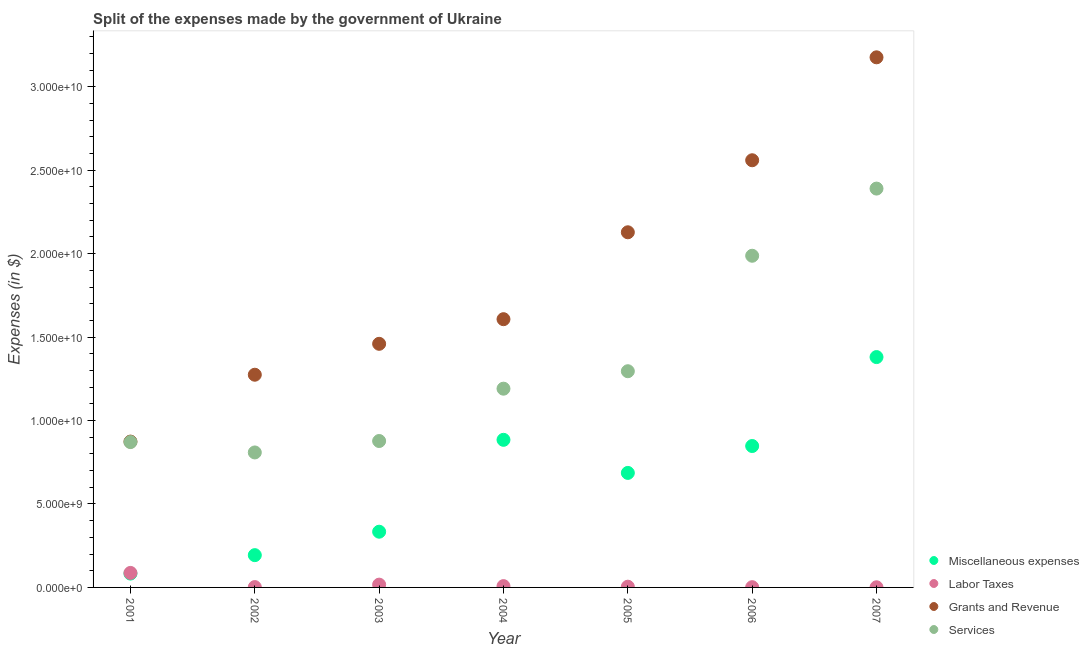Is the number of dotlines equal to the number of legend labels?
Ensure brevity in your answer.  Yes. What is the amount spent on services in 2003?
Ensure brevity in your answer.  8.77e+09. Across all years, what is the maximum amount spent on miscellaneous expenses?
Provide a succinct answer. 1.38e+1. Across all years, what is the minimum amount spent on grants and revenue?
Ensure brevity in your answer.  8.74e+09. What is the total amount spent on miscellaneous expenses in the graph?
Your response must be concise. 4.41e+1. What is the difference between the amount spent on grants and revenue in 2001 and that in 2002?
Your response must be concise. -4.01e+09. What is the difference between the amount spent on services in 2004 and the amount spent on miscellaneous expenses in 2005?
Give a very brief answer. 5.05e+09. What is the average amount spent on miscellaneous expenses per year?
Make the answer very short. 6.30e+09. In the year 2003, what is the difference between the amount spent on services and amount spent on labor taxes?
Your answer should be compact. 8.60e+09. In how many years, is the amount spent on labor taxes greater than 23000000000 $?
Your answer should be compact. 0. What is the ratio of the amount spent on services in 2004 to that in 2005?
Ensure brevity in your answer.  0.92. What is the difference between the highest and the second highest amount spent on miscellaneous expenses?
Offer a very short reply. 4.96e+09. What is the difference between the highest and the lowest amount spent on grants and revenue?
Make the answer very short. 2.30e+1. In how many years, is the amount spent on grants and revenue greater than the average amount spent on grants and revenue taken over all years?
Provide a short and direct response. 3. Is the sum of the amount spent on labor taxes in 2003 and 2004 greater than the maximum amount spent on services across all years?
Offer a terse response. No. Is it the case that in every year, the sum of the amount spent on miscellaneous expenses and amount spent on labor taxes is greater than the amount spent on grants and revenue?
Keep it short and to the point. No. Is the amount spent on services strictly greater than the amount spent on labor taxes over the years?
Provide a short and direct response. Yes. Is the amount spent on services strictly less than the amount spent on miscellaneous expenses over the years?
Provide a short and direct response. No. What is the difference between two consecutive major ticks on the Y-axis?
Your response must be concise. 5.00e+09. Are the values on the major ticks of Y-axis written in scientific E-notation?
Offer a terse response. Yes. How many legend labels are there?
Offer a very short reply. 4. What is the title of the graph?
Your response must be concise. Split of the expenses made by the government of Ukraine. What is the label or title of the Y-axis?
Your answer should be very brief. Expenses (in $). What is the Expenses (in $) of Miscellaneous expenses in 2001?
Offer a very short reply. 8.29e+08. What is the Expenses (in $) in Labor Taxes in 2001?
Provide a succinct answer. 8.69e+08. What is the Expenses (in $) in Grants and Revenue in 2001?
Make the answer very short. 8.74e+09. What is the Expenses (in $) in Services in 2001?
Provide a short and direct response. 8.71e+09. What is the Expenses (in $) of Miscellaneous expenses in 2002?
Make the answer very short. 1.93e+09. What is the Expenses (in $) of Labor Taxes in 2002?
Provide a succinct answer. 2.07e+07. What is the Expenses (in $) of Grants and Revenue in 2002?
Your answer should be compact. 1.27e+1. What is the Expenses (in $) in Services in 2002?
Offer a very short reply. 8.09e+09. What is the Expenses (in $) in Miscellaneous expenses in 2003?
Offer a terse response. 3.34e+09. What is the Expenses (in $) of Labor Taxes in 2003?
Provide a short and direct response. 1.67e+08. What is the Expenses (in $) in Grants and Revenue in 2003?
Offer a very short reply. 1.46e+1. What is the Expenses (in $) in Services in 2003?
Give a very brief answer. 8.77e+09. What is the Expenses (in $) in Miscellaneous expenses in 2004?
Make the answer very short. 8.84e+09. What is the Expenses (in $) of Labor Taxes in 2004?
Offer a terse response. 7.85e+07. What is the Expenses (in $) of Grants and Revenue in 2004?
Offer a terse response. 1.61e+1. What is the Expenses (in $) of Services in 2004?
Offer a very short reply. 1.19e+1. What is the Expenses (in $) in Miscellaneous expenses in 2005?
Provide a short and direct response. 6.86e+09. What is the Expenses (in $) of Labor Taxes in 2005?
Ensure brevity in your answer.  4.35e+07. What is the Expenses (in $) in Grants and Revenue in 2005?
Offer a very short reply. 2.13e+1. What is the Expenses (in $) of Services in 2005?
Offer a terse response. 1.30e+1. What is the Expenses (in $) of Miscellaneous expenses in 2006?
Your answer should be very brief. 8.47e+09. What is the Expenses (in $) in Labor Taxes in 2006?
Your response must be concise. 1.44e+07. What is the Expenses (in $) of Grants and Revenue in 2006?
Provide a succinct answer. 2.56e+1. What is the Expenses (in $) of Services in 2006?
Ensure brevity in your answer.  1.99e+1. What is the Expenses (in $) in Miscellaneous expenses in 2007?
Offer a terse response. 1.38e+1. What is the Expenses (in $) in Labor Taxes in 2007?
Keep it short and to the point. 8.40e+06. What is the Expenses (in $) of Grants and Revenue in 2007?
Provide a succinct answer. 3.18e+1. What is the Expenses (in $) of Services in 2007?
Your answer should be very brief. 2.39e+1. Across all years, what is the maximum Expenses (in $) of Miscellaneous expenses?
Make the answer very short. 1.38e+1. Across all years, what is the maximum Expenses (in $) of Labor Taxes?
Your answer should be very brief. 8.69e+08. Across all years, what is the maximum Expenses (in $) of Grants and Revenue?
Provide a succinct answer. 3.18e+1. Across all years, what is the maximum Expenses (in $) of Services?
Offer a terse response. 2.39e+1. Across all years, what is the minimum Expenses (in $) in Miscellaneous expenses?
Ensure brevity in your answer.  8.29e+08. Across all years, what is the minimum Expenses (in $) of Labor Taxes?
Keep it short and to the point. 8.40e+06. Across all years, what is the minimum Expenses (in $) in Grants and Revenue?
Offer a terse response. 8.74e+09. Across all years, what is the minimum Expenses (in $) in Services?
Offer a terse response. 8.09e+09. What is the total Expenses (in $) of Miscellaneous expenses in the graph?
Make the answer very short. 4.41e+1. What is the total Expenses (in $) in Labor Taxes in the graph?
Give a very brief answer. 1.20e+09. What is the total Expenses (in $) in Grants and Revenue in the graph?
Your response must be concise. 1.31e+11. What is the total Expenses (in $) in Services in the graph?
Your response must be concise. 9.42e+1. What is the difference between the Expenses (in $) in Miscellaneous expenses in 2001 and that in 2002?
Keep it short and to the point. -1.10e+09. What is the difference between the Expenses (in $) of Labor Taxes in 2001 and that in 2002?
Ensure brevity in your answer.  8.48e+08. What is the difference between the Expenses (in $) in Grants and Revenue in 2001 and that in 2002?
Ensure brevity in your answer.  -4.01e+09. What is the difference between the Expenses (in $) of Services in 2001 and that in 2002?
Ensure brevity in your answer.  6.23e+08. What is the difference between the Expenses (in $) of Miscellaneous expenses in 2001 and that in 2003?
Provide a succinct answer. -2.51e+09. What is the difference between the Expenses (in $) in Labor Taxes in 2001 and that in 2003?
Provide a succinct answer. 7.02e+08. What is the difference between the Expenses (in $) in Grants and Revenue in 2001 and that in 2003?
Make the answer very short. -5.86e+09. What is the difference between the Expenses (in $) of Services in 2001 and that in 2003?
Your response must be concise. -6.23e+07. What is the difference between the Expenses (in $) in Miscellaneous expenses in 2001 and that in 2004?
Make the answer very short. -8.01e+09. What is the difference between the Expenses (in $) in Labor Taxes in 2001 and that in 2004?
Your answer should be very brief. 7.91e+08. What is the difference between the Expenses (in $) in Grants and Revenue in 2001 and that in 2004?
Your answer should be compact. -7.33e+09. What is the difference between the Expenses (in $) of Services in 2001 and that in 2004?
Your response must be concise. -3.20e+09. What is the difference between the Expenses (in $) in Miscellaneous expenses in 2001 and that in 2005?
Offer a terse response. -6.03e+09. What is the difference between the Expenses (in $) of Labor Taxes in 2001 and that in 2005?
Ensure brevity in your answer.  8.26e+08. What is the difference between the Expenses (in $) in Grants and Revenue in 2001 and that in 2005?
Your answer should be very brief. -1.25e+1. What is the difference between the Expenses (in $) of Services in 2001 and that in 2005?
Your answer should be very brief. -4.24e+09. What is the difference between the Expenses (in $) in Miscellaneous expenses in 2001 and that in 2006?
Provide a succinct answer. -7.64e+09. What is the difference between the Expenses (in $) in Labor Taxes in 2001 and that in 2006?
Your response must be concise. 8.55e+08. What is the difference between the Expenses (in $) of Grants and Revenue in 2001 and that in 2006?
Provide a succinct answer. -1.69e+1. What is the difference between the Expenses (in $) in Services in 2001 and that in 2006?
Keep it short and to the point. -1.12e+1. What is the difference between the Expenses (in $) in Miscellaneous expenses in 2001 and that in 2007?
Provide a short and direct response. -1.30e+1. What is the difference between the Expenses (in $) in Labor Taxes in 2001 and that in 2007?
Provide a short and direct response. 8.61e+08. What is the difference between the Expenses (in $) of Grants and Revenue in 2001 and that in 2007?
Give a very brief answer. -2.30e+1. What is the difference between the Expenses (in $) in Services in 2001 and that in 2007?
Give a very brief answer. -1.52e+1. What is the difference between the Expenses (in $) of Miscellaneous expenses in 2002 and that in 2003?
Your answer should be very brief. -1.40e+09. What is the difference between the Expenses (in $) in Labor Taxes in 2002 and that in 2003?
Your answer should be compact. -1.47e+08. What is the difference between the Expenses (in $) in Grants and Revenue in 2002 and that in 2003?
Offer a very short reply. -1.85e+09. What is the difference between the Expenses (in $) of Services in 2002 and that in 2003?
Provide a succinct answer. -6.85e+08. What is the difference between the Expenses (in $) in Miscellaneous expenses in 2002 and that in 2004?
Ensure brevity in your answer.  -6.91e+09. What is the difference between the Expenses (in $) of Labor Taxes in 2002 and that in 2004?
Keep it short and to the point. -5.78e+07. What is the difference between the Expenses (in $) of Grants and Revenue in 2002 and that in 2004?
Ensure brevity in your answer.  -3.33e+09. What is the difference between the Expenses (in $) of Services in 2002 and that in 2004?
Give a very brief answer. -3.82e+09. What is the difference between the Expenses (in $) of Miscellaneous expenses in 2002 and that in 2005?
Provide a short and direct response. -4.93e+09. What is the difference between the Expenses (in $) in Labor Taxes in 2002 and that in 2005?
Provide a succinct answer. -2.28e+07. What is the difference between the Expenses (in $) of Grants and Revenue in 2002 and that in 2005?
Offer a very short reply. -8.53e+09. What is the difference between the Expenses (in $) of Services in 2002 and that in 2005?
Your answer should be very brief. -4.87e+09. What is the difference between the Expenses (in $) of Miscellaneous expenses in 2002 and that in 2006?
Provide a succinct answer. -6.54e+09. What is the difference between the Expenses (in $) of Labor Taxes in 2002 and that in 2006?
Keep it short and to the point. 6.30e+06. What is the difference between the Expenses (in $) in Grants and Revenue in 2002 and that in 2006?
Give a very brief answer. -1.29e+1. What is the difference between the Expenses (in $) in Services in 2002 and that in 2006?
Ensure brevity in your answer.  -1.18e+1. What is the difference between the Expenses (in $) in Miscellaneous expenses in 2002 and that in 2007?
Offer a very short reply. -1.19e+1. What is the difference between the Expenses (in $) of Labor Taxes in 2002 and that in 2007?
Your answer should be compact. 1.23e+07. What is the difference between the Expenses (in $) of Grants and Revenue in 2002 and that in 2007?
Keep it short and to the point. -1.90e+1. What is the difference between the Expenses (in $) of Services in 2002 and that in 2007?
Your answer should be very brief. -1.58e+1. What is the difference between the Expenses (in $) in Miscellaneous expenses in 2003 and that in 2004?
Provide a short and direct response. -5.51e+09. What is the difference between the Expenses (in $) of Labor Taxes in 2003 and that in 2004?
Provide a succinct answer. 8.90e+07. What is the difference between the Expenses (in $) in Grants and Revenue in 2003 and that in 2004?
Offer a terse response. -1.48e+09. What is the difference between the Expenses (in $) in Services in 2003 and that in 2004?
Keep it short and to the point. -3.14e+09. What is the difference between the Expenses (in $) in Miscellaneous expenses in 2003 and that in 2005?
Make the answer very short. -3.52e+09. What is the difference between the Expenses (in $) in Labor Taxes in 2003 and that in 2005?
Offer a terse response. 1.24e+08. What is the difference between the Expenses (in $) of Grants and Revenue in 2003 and that in 2005?
Provide a short and direct response. -6.68e+09. What is the difference between the Expenses (in $) of Services in 2003 and that in 2005?
Your response must be concise. -4.18e+09. What is the difference between the Expenses (in $) of Miscellaneous expenses in 2003 and that in 2006?
Provide a succinct answer. -5.13e+09. What is the difference between the Expenses (in $) in Labor Taxes in 2003 and that in 2006?
Offer a terse response. 1.53e+08. What is the difference between the Expenses (in $) in Grants and Revenue in 2003 and that in 2006?
Ensure brevity in your answer.  -1.10e+1. What is the difference between the Expenses (in $) of Services in 2003 and that in 2006?
Provide a short and direct response. -1.11e+1. What is the difference between the Expenses (in $) of Miscellaneous expenses in 2003 and that in 2007?
Give a very brief answer. -1.05e+1. What is the difference between the Expenses (in $) of Labor Taxes in 2003 and that in 2007?
Keep it short and to the point. 1.59e+08. What is the difference between the Expenses (in $) of Grants and Revenue in 2003 and that in 2007?
Give a very brief answer. -1.72e+1. What is the difference between the Expenses (in $) in Services in 2003 and that in 2007?
Your answer should be compact. -1.51e+1. What is the difference between the Expenses (in $) in Miscellaneous expenses in 2004 and that in 2005?
Your answer should be compact. 1.98e+09. What is the difference between the Expenses (in $) in Labor Taxes in 2004 and that in 2005?
Keep it short and to the point. 3.50e+07. What is the difference between the Expenses (in $) in Grants and Revenue in 2004 and that in 2005?
Make the answer very short. -5.21e+09. What is the difference between the Expenses (in $) of Services in 2004 and that in 2005?
Provide a succinct answer. -1.05e+09. What is the difference between the Expenses (in $) of Miscellaneous expenses in 2004 and that in 2006?
Keep it short and to the point. 3.71e+08. What is the difference between the Expenses (in $) of Labor Taxes in 2004 and that in 2006?
Provide a succinct answer. 6.41e+07. What is the difference between the Expenses (in $) in Grants and Revenue in 2004 and that in 2006?
Ensure brevity in your answer.  -9.52e+09. What is the difference between the Expenses (in $) of Services in 2004 and that in 2006?
Provide a short and direct response. -7.96e+09. What is the difference between the Expenses (in $) in Miscellaneous expenses in 2004 and that in 2007?
Keep it short and to the point. -4.96e+09. What is the difference between the Expenses (in $) in Labor Taxes in 2004 and that in 2007?
Your answer should be very brief. 7.01e+07. What is the difference between the Expenses (in $) in Grants and Revenue in 2004 and that in 2007?
Provide a succinct answer. -1.57e+1. What is the difference between the Expenses (in $) of Services in 2004 and that in 2007?
Your answer should be very brief. -1.20e+1. What is the difference between the Expenses (in $) in Miscellaneous expenses in 2005 and that in 2006?
Your answer should be compact. -1.61e+09. What is the difference between the Expenses (in $) in Labor Taxes in 2005 and that in 2006?
Provide a succinct answer. 2.91e+07. What is the difference between the Expenses (in $) of Grants and Revenue in 2005 and that in 2006?
Your response must be concise. -4.32e+09. What is the difference between the Expenses (in $) in Services in 2005 and that in 2006?
Offer a very short reply. -6.92e+09. What is the difference between the Expenses (in $) of Miscellaneous expenses in 2005 and that in 2007?
Make the answer very short. -6.94e+09. What is the difference between the Expenses (in $) in Labor Taxes in 2005 and that in 2007?
Keep it short and to the point. 3.51e+07. What is the difference between the Expenses (in $) of Grants and Revenue in 2005 and that in 2007?
Your response must be concise. -1.05e+1. What is the difference between the Expenses (in $) in Services in 2005 and that in 2007?
Give a very brief answer. -1.09e+1. What is the difference between the Expenses (in $) of Miscellaneous expenses in 2006 and that in 2007?
Keep it short and to the point. -5.33e+09. What is the difference between the Expenses (in $) of Labor Taxes in 2006 and that in 2007?
Your response must be concise. 6.00e+06. What is the difference between the Expenses (in $) in Grants and Revenue in 2006 and that in 2007?
Your answer should be compact. -6.17e+09. What is the difference between the Expenses (in $) in Services in 2006 and that in 2007?
Provide a succinct answer. -4.02e+09. What is the difference between the Expenses (in $) of Miscellaneous expenses in 2001 and the Expenses (in $) of Labor Taxes in 2002?
Your answer should be very brief. 8.09e+08. What is the difference between the Expenses (in $) in Miscellaneous expenses in 2001 and the Expenses (in $) in Grants and Revenue in 2002?
Keep it short and to the point. -1.19e+1. What is the difference between the Expenses (in $) in Miscellaneous expenses in 2001 and the Expenses (in $) in Services in 2002?
Provide a short and direct response. -7.26e+09. What is the difference between the Expenses (in $) in Labor Taxes in 2001 and the Expenses (in $) in Grants and Revenue in 2002?
Give a very brief answer. -1.19e+1. What is the difference between the Expenses (in $) of Labor Taxes in 2001 and the Expenses (in $) of Services in 2002?
Ensure brevity in your answer.  -7.22e+09. What is the difference between the Expenses (in $) of Grants and Revenue in 2001 and the Expenses (in $) of Services in 2002?
Provide a short and direct response. 6.51e+08. What is the difference between the Expenses (in $) in Miscellaneous expenses in 2001 and the Expenses (in $) in Labor Taxes in 2003?
Ensure brevity in your answer.  6.62e+08. What is the difference between the Expenses (in $) of Miscellaneous expenses in 2001 and the Expenses (in $) of Grants and Revenue in 2003?
Your answer should be compact. -1.38e+1. What is the difference between the Expenses (in $) in Miscellaneous expenses in 2001 and the Expenses (in $) in Services in 2003?
Provide a short and direct response. -7.94e+09. What is the difference between the Expenses (in $) in Labor Taxes in 2001 and the Expenses (in $) in Grants and Revenue in 2003?
Keep it short and to the point. -1.37e+1. What is the difference between the Expenses (in $) of Labor Taxes in 2001 and the Expenses (in $) of Services in 2003?
Provide a succinct answer. -7.90e+09. What is the difference between the Expenses (in $) of Grants and Revenue in 2001 and the Expenses (in $) of Services in 2003?
Give a very brief answer. -3.42e+07. What is the difference between the Expenses (in $) in Miscellaneous expenses in 2001 and the Expenses (in $) in Labor Taxes in 2004?
Your answer should be compact. 7.51e+08. What is the difference between the Expenses (in $) in Miscellaneous expenses in 2001 and the Expenses (in $) in Grants and Revenue in 2004?
Provide a succinct answer. -1.52e+1. What is the difference between the Expenses (in $) in Miscellaneous expenses in 2001 and the Expenses (in $) in Services in 2004?
Give a very brief answer. -1.11e+1. What is the difference between the Expenses (in $) in Labor Taxes in 2001 and the Expenses (in $) in Grants and Revenue in 2004?
Ensure brevity in your answer.  -1.52e+1. What is the difference between the Expenses (in $) of Labor Taxes in 2001 and the Expenses (in $) of Services in 2004?
Your answer should be very brief. -1.10e+1. What is the difference between the Expenses (in $) in Grants and Revenue in 2001 and the Expenses (in $) in Services in 2004?
Offer a terse response. -3.17e+09. What is the difference between the Expenses (in $) in Miscellaneous expenses in 2001 and the Expenses (in $) in Labor Taxes in 2005?
Provide a short and direct response. 7.86e+08. What is the difference between the Expenses (in $) in Miscellaneous expenses in 2001 and the Expenses (in $) in Grants and Revenue in 2005?
Your answer should be very brief. -2.04e+1. What is the difference between the Expenses (in $) of Miscellaneous expenses in 2001 and the Expenses (in $) of Services in 2005?
Keep it short and to the point. -1.21e+1. What is the difference between the Expenses (in $) of Labor Taxes in 2001 and the Expenses (in $) of Grants and Revenue in 2005?
Provide a succinct answer. -2.04e+1. What is the difference between the Expenses (in $) of Labor Taxes in 2001 and the Expenses (in $) of Services in 2005?
Offer a very short reply. -1.21e+1. What is the difference between the Expenses (in $) of Grants and Revenue in 2001 and the Expenses (in $) of Services in 2005?
Offer a very short reply. -4.22e+09. What is the difference between the Expenses (in $) in Miscellaneous expenses in 2001 and the Expenses (in $) in Labor Taxes in 2006?
Offer a terse response. 8.15e+08. What is the difference between the Expenses (in $) of Miscellaneous expenses in 2001 and the Expenses (in $) of Grants and Revenue in 2006?
Your answer should be very brief. -2.48e+1. What is the difference between the Expenses (in $) in Miscellaneous expenses in 2001 and the Expenses (in $) in Services in 2006?
Your answer should be compact. -1.90e+1. What is the difference between the Expenses (in $) in Labor Taxes in 2001 and the Expenses (in $) in Grants and Revenue in 2006?
Provide a short and direct response. -2.47e+1. What is the difference between the Expenses (in $) of Labor Taxes in 2001 and the Expenses (in $) of Services in 2006?
Your answer should be very brief. -1.90e+1. What is the difference between the Expenses (in $) of Grants and Revenue in 2001 and the Expenses (in $) of Services in 2006?
Provide a succinct answer. -1.11e+1. What is the difference between the Expenses (in $) in Miscellaneous expenses in 2001 and the Expenses (in $) in Labor Taxes in 2007?
Your answer should be very brief. 8.21e+08. What is the difference between the Expenses (in $) of Miscellaneous expenses in 2001 and the Expenses (in $) of Grants and Revenue in 2007?
Ensure brevity in your answer.  -3.09e+1. What is the difference between the Expenses (in $) of Miscellaneous expenses in 2001 and the Expenses (in $) of Services in 2007?
Provide a short and direct response. -2.31e+1. What is the difference between the Expenses (in $) of Labor Taxes in 2001 and the Expenses (in $) of Grants and Revenue in 2007?
Make the answer very short. -3.09e+1. What is the difference between the Expenses (in $) in Labor Taxes in 2001 and the Expenses (in $) in Services in 2007?
Provide a succinct answer. -2.30e+1. What is the difference between the Expenses (in $) of Grants and Revenue in 2001 and the Expenses (in $) of Services in 2007?
Provide a short and direct response. -1.52e+1. What is the difference between the Expenses (in $) of Miscellaneous expenses in 2002 and the Expenses (in $) of Labor Taxes in 2003?
Your response must be concise. 1.77e+09. What is the difference between the Expenses (in $) in Miscellaneous expenses in 2002 and the Expenses (in $) in Grants and Revenue in 2003?
Make the answer very short. -1.27e+1. What is the difference between the Expenses (in $) in Miscellaneous expenses in 2002 and the Expenses (in $) in Services in 2003?
Give a very brief answer. -6.84e+09. What is the difference between the Expenses (in $) of Labor Taxes in 2002 and the Expenses (in $) of Grants and Revenue in 2003?
Provide a succinct answer. -1.46e+1. What is the difference between the Expenses (in $) in Labor Taxes in 2002 and the Expenses (in $) in Services in 2003?
Make the answer very short. -8.75e+09. What is the difference between the Expenses (in $) of Grants and Revenue in 2002 and the Expenses (in $) of Services in 2003?
Keep it short and to the point. 3.97e+09. What is the difference between the Expenses (in $) of Miscellaneous expenses in 2002 and the Expenses (in $) of Labor Taxes in 2004?
Your answer should be compact. 1.86e+09. What is the difference between the Expenses (in $) of Miscellaneous expenses in 2002 and the Expenses (in $) of Grants and Revenue in 2004?
Offer a very short reply. -1.41e+1. What is the difference between the Expenses (in $) in Miscellaneous expenses in 2002 and the Expenses (in $) in Services in 2004?
Offer a very short reply. -9.97e+09. What is the difference between the Expenses (in $) in Labor Taxes in 2002 and the Expenses (in $) in Grants and Revenue in 2004?
Provide a succinct answer. -1.61e+1. What is the difference between the Expenses (in $) in Labor Taxes in 2002 and the Expenses (in $) in Services in 2004?
Ensure brevity in your answer.  -1.19e+1. What is the difference between the Expenses (in $) in Grants and Revenue in 2002 and the Expenses (in $) in Services in 2004?
Make the answer very short. 8.36e+08. What is the difference between the Expenses (in $) of Miscellaneous expenses in 2002 and the Expenses (in $) of Labor Taxes in 2005?
Your response must be concise. 1.89e+09. What is the difference between the Expenses (in $) of Miscellaneous expenses in 2002 and the Expenses (in $) of Grants and Revenue in 2005?
Offer a terse response. -1.93e+1. What is the difference between the Expenses (in $) of Miscellaneous expenses in 2002 and the Expenses (in $) of Services in 2005?
Keep it short and to the point. -1.10e+1. What is the difference between the Expenses (in $) in Labor Taxes in 2002 and the Expenses (in $) in Grants and Revenue in 2005?
Make the answer very short. -2.13e+1. What is the difference between the Expenses (in $) in Labor Taxes in 2002 and the Expenses (in $) in Services in 2005?
Keep it short and to the point. -1.29e+1. What is the difference between the Expenses (in $) of Grants and Revenue in 2002 and the Expenses (in $) of Services in 2005?
Offer a terse response. -2.10e+08. What is the difference between the Expenses (in $) of Miscellaneous expenses in 2002 and the Expenses (in $) of Labor Taxes in 2006?
Provide a short and direct response. 1.92e+09. What is the difference between the Expenses (in $) of Miscellaneous expenses in 2002 and the Expenses (in $) of Grants and Revenue in 2006?
Your answer should be compact. -2.37e+1. What is the difference between the Expenses (in $) in Miscellaneous expenses in 2002 and the Expenses (in $) in Services in 2006?
Provide a short and direct response. -1.79e+1. What is the difference between the Expenses (in $) in Labor Taxes in 2002 and the Expenses (in $) in Grants and Revenue in 2006?
Your response must be concise. -2.56e+1. What is the difference between the Expenses (in $) in Labor Taxes in 2002 and the Expenses (in $) in Services in 2006?
Offer a very short reply. -1.99e+1. What is the difference between the Expenses (in $) in Grants and Revenue in 2002 and the Expenses (in $) in Services in 2006?
Your answer should be very brief. -7.13e+09. What is the difference between the Expenses (in $) in Miscellaneous expenses in 2002 and the Expenses (in $) in Labor Taxes in 2007?
Make the answer very short. 1.93e+09. What is the difference between the Expenses (in $) of Miscellaneous expenses in 2002 and the Expenses (in $) of Grants and Revenue in 2007?
Make the answer very short. -2.98e+1. What is the difference between the Expenses (in $) of Miscellaneous expenses in 2002 and the Expenses (in $) of Services in 2007?
Your answer should be compact. -2.20e+1. What is the difference between the Expenses (in $) of Labor Taxes in 2002 and the Expenses (in $) of Grants and Revenue in 2007?
Keep it short and to the point. -3.17e+1. What is the difference between the Expenses (in $) in Labor Taxes in 2002 and the Expenses (in $) in Services in 2007?
Ensure brevity in your answer.  -2.39e+1. What is the difference between the Expenses (in $) in Grants and Revenue in 2002 and the Expenses (in $) in Services in 2007?
Your answer should be very brief. -1.12e+1. What is the difference between the Expenses (in $) of Miscellaneous expenses in 2003 and the Expenses (in $) of Labor Taxes in 2004?
Keep it short and to the point. 3.26e+09. What is the difference between the Expenses (in $) of Miscellaneous expenses in 2003 and the Expenses (in $) of Grants and Revenue in 2004?
Your answer should be compact. -1.27e+1. What is the difference between the Expenses (in $) of Miscellaneous expenses in 2003 and the Expenses (in $) of Services in 2004?
Make the answer very short. -8.57e+09. What is the difference between the Expenses (in $) of Labor Taxes in 2003 and the Expenses (in $) of Grants and Revenue in 2004?
Ensure brevity in your answer.  -1.59e+1. What is the difference between the Expenses (in $) of Labor Taxes in 2003 and the Expenses (in $) of Services in 2004?
Provide a short and direct response. -1.17e+1. What is the difference between the Expenses (in $) of Grants and Revenue in 2003 and the Expenses (in $) of Services in 2004?
Offer a terse response. 2.69e+09. What is the difference between the Expenses (in $) of Miscellaneous expenses in 2003 and the Expenses (in $) of Labor Taxes in 2005?
Ensure brevity in your answer.  3.29e+09. What is the difference between the Expenses (in $) in Miscellaneous expenses in 2003 and the Expenses (in $) in Grants and Revenue in 2005?
Give a very brief answer. -1.79e+1. What is the difference between the Expenses (in $) in Miscellaneous expenses in 2003 and the Expenses (in $) in Services in 2005?
Your response must be concise. -9.62e+09. What is the difference between the Expenses (in $) in Labor Taxes in 2003 and the Expenses (in $) in Grants and Revenue in 2005?
Provide a succinct answer. -2.11e+1. What is the difference between the Expenses (in $) in Labor Taxes in 2003 and the Expenses (in $) in Services in 2005?
Give a very brief answer. -1.28e+1. What is the difference between the Expenses (in $) in Grants and Revenue in 2003 and the Expenses (in $) in Services in 2005?
Your response must be concise. 1.64e+09. What is the difference between the Expenses (in $) in Miscellaneous expenses in 2003 and the Expenses (in $) in Labor Taxes in 2006?
Offer a terse response. 3.32e+09. What is the difference between the Expenses (in $) in Miscellaneous expenses in 2003 and the Expenses (in $) in Grants and Revenue in 2006?
Provide a short and direct response. -2.23e+1. What is the difference between the Expenses (in $) in Miscellaneous expenses in 2003 and the Expenses (in $) in Services in 2006?
Ensure brevity in your answer.  -1.65e+1. What is the difference between the Expenses (in $) in Labor Taxes in 2003 and the Expenses (in $) in Grants and Revenue in 2006?
Provide a succinct answer. -2.54e+1. What is the difference between the Expenses (in $) in Labor Taxes in 2003 and the Expenses (in $) in Services in 2006?
Your answer should be compact. -1.97e+1. What is the difference between the Expenses (in $) of Grants and Revenue in 2003 and the Expenses (in $) of Services in 2006?
Make the answer very short. -5.28e+09. What is the difference between the Expenses (in $) of Miscellaneous expenses in 2003 and the Expenses (in $) of Labor Taxes in 2007?
Ensure brevity in your answer.  3.33e+09. What is the difference between the Expenses (in $) in Miscellaneous expenses in 2003 and the Expenses (in $) in Grants and Revenue in 2007?
Your answer should be compact. -2.84e+1. What is the difference between the Expenses (in $) of Miscellaneous expenses in 2003 and the Expenses (in $) of Services in 2007?
Your response must be concise. -2.06e+1. What is the difference between the Expenses (in $) in Labor Taxes in 2003 and the Expenses (in $) in Grants and Revenue in 2007?
Offer a terse response. -3.16e+1. What is the difference between the Expenses (in $) of Labor Taxes in 2003 and the Expenses (in $) of Services in 2007?
Provide a succinct answer. -2.37e+1. What is the difference between the Expenses (in $) of Grants and Revenue in 2003 and the Expenses (in $) of Services in 2007?
Your answer should be compact. -9.30e+09. What is the difference between the Expenses (in $) of Miscellaneous expenses in 2004 and the Expenses (in $) of Labor Taxes in 2005?
Your response must be concise. 8.80e+09. What is the difference between the Expenses (in $) in Miscellaneous expenses in 2004 and the Expenses (in $) in Grants and Revenue in 2005?
Your answer should be compact. -1.24e+1. What is the difference between the Expenses (in $) of Miscellaneous expenses in 2004 and the Expenses (in $) of Services in 2005?
Offer a terse response. -4.11e+09. What is the difference between the Expenses (in $) in Labor Taxes in 2004 and the Expenses (in $) in Grants and Revenue in 2005?
Provide a succinct answer. -2.12e+1. What is the difference between the Expenses (in $) of Labor Taxes in 2004 and the Expenses (in $) of Services in 2005?
Offer a very short reply. -1.29e+1. What is the difference between the Expenses (in $) of Grants and Revenue in 2004 and the Expenses (in $) of Services in 2005?
Offer a terse response. 3.12e+09. What is the difference between the Expenses (in $) in Miscellaneous expenses in 2004 and the Expenses (in $) in Labor Taxes in 2006?
Your response must be concise. 8.83e+09. What is the difference between the Expenses (in $) in Miscellaneous expenses in 2004 and the Expenses (in $) in Grants and Revenue in 2006?
Ensure brevity in your answer.  -1.68e+1. What is the difference between the Expenses (in $) in Miscellaneous expenses in 2004 and the Expenses (in $) in Services in 2006?
Your response must be concise. -1.10e+1. What is the difference between the Expenses (in $) in Labor Taxes in 2004 and the Expenses (in $) in Grants and Revenue in 2006?
Your answer should be compact. -2.55e+1. What is the difference between the Expenses (in $) of Labor Taxes in 2004 and the Expenses (in $) of Services in 2006?
Give a very brief answer. -1.98e+1. What is the difference between the Expenses (in $) in Grants and Revenue in 2004 and the Expenses (in $) in Services in 2006?
Your answer should be very brief. -3.80e+09. What is the difference between the Expenses (in $) in Miscellaneous expenses in 2004 and the Expenses (in $) in Labor Taxes in 2007?
Your answer should be compact. 8.84e+09. What is the difference between the Expenses (in $) in Miscellaneous expenses in 2004 and the Expenses (in $) in Grants and Revenue in 2007?
Your answer should be very brief. -2.29e+1. What is the difference between the Expenses (in $) in Miscellaneous expenses in 2004 and the Expenses (in $) in Services in 2007?
Offer a very short reply. -1.51e+1. What is the difference between the Expenses (in $) in Labor Taxes in 2004 and the Expenses (in $) in Grants and Revenue in 2007?
Provide a succinct answer. -3.17e+1. What is the difference between the Expenses (in $) in Labor Taxes in 2004 and the Expenses (in $) in Services in 2007?
Your answer should be very brief. -2.38e+1. What is the difference between the Expenses (in $) of Grants and Revenue in 2004 and the Expenses (in $) of Services in 2007?
Your answer should be very brief. -7.82e+09. What is the difference between the Expenses (in $) of Miscellaneous expenses in 2005 and the Expenses (in $) of Labor Taxes in 2006?
Your answer should be very brief. 6.85e+09. What is the difference between the Expenses (in $) in Miscellaneous expenses in 2005 and the Expenses (in $) in Grants and Revenue in 2006?
Provide a short and direct response. -1.87e+1. What is the difference between the Expenses (in $) in Miscellaneous expenses in 2005 and the Expenses (in $) in Services in 2006?
Your response must be concise. -1.30e+1. What is the difference between the Expenses (in $) of Labor Taxes in 2005 and the Expenses (in $) of Grants and Revenue in 2006?
Offer a very short reply. -2.56e+1. What is the difference between the Expenses (in $) in Labor Taxes in 2005 and the Expenses (in $) in Services in 2006?
Your answer should be very brief. -1.98e+1. What is the difference between the Expenses (in $) in Grants and Revenue in 2005 and the Expenses (in $) in Services in 2006?
Offer a terse response. 1.41e+09. What is the difference between the Expenses (in $) in Miscellaneous expenses in 2005 and the Expenses (in $) in Labor Taxes in 2007?
Provide a short and direct response. 6.85e+09. What is the difference between the Expenses (in $) of Miscellaneous expenses in 2005 and the Expenses (in $) of Grants and Revenue in 2007?
Provide a succinct answer. -2.49e+1. What is the difference between the Expenses (in $) in Miscellaneous expenses in 2005 and the Expenses (in $) in Services in 2007?
Keep it short and to the point. -1.70e+1. What is the difference between the Expenses (in $) of Labor Taxes in 2005 and the Expenses (in $) of Grants and Revenue in 2007?
Give a very brief answer. -3.17e+1. What is the difference between the Expenses (in $) in Labor Taxes in 2005 and the Expenses (in $) in Services in 2007?
Make the answer very short. -2.39e+1. What is the difference between the Expenses (in $) in Grants and Revenue in 2005 and the Expenses (in $) in Services in 2007?
Keep it short and to the point. -2.62e+09. What is the difference between the Expenses (in $) of Miscellaneous expenses in 2006 and the Expenses (in $) of Labor Taxes in 2007?
Offer a terse response. 8.46e+09. What is the difference between the Expenses (in $) in Miscellaneous expenses in 2006 and the Expenses (in $) in Grants and Revenue in 2007?
Make the answer very short. -2.33e+1. What is the difference between the Expenses (in $) in Miscellaneous expenses in 2006 and the Expenses (in $) in Services in 2007?
Your answer should be compact. -1.54e+1. What is the difference between the Expenses (in $) of Labor Taxes in 2006 and the Expenses (in $) of Grants and Revenue in 2007?
Provide a short and direct response. -3.17e+1. What is the difference between the Expenses (in $) of Labor Taxes in 2006 and the Expenses (in $) of Services in 2007?
Provide a short and direct response. -2.39e+1. What is the difference between the Expenses (in $) of Grants and Revenue in 2006 and the Expenses (in $) of Services in 2007?
Provide a succinct answer. 1.70e+09. What is the average Expenses (in $) in Miscellaneous expenses per year?
Keep it short and to the point. 6.30e+09. What is the average Expenses (in $) of Labor Taxes per year?
Provide a succinct answer. 1.72e+08. What is the average Expenses (in $) in Grants and Revenue per year?
Offer a terse response. 1.87e+1. What is the average Expenses (in $) of Services per year?
Make the answer very short. 1.35e+1. In the year 2001, what is the difference between the Expenses (in $) in Miscellaneous expenses and Expenses (in $) in Labor Taxes?
Offer a very short reply. -3.98e+07. In the year 2001, what is the difference between the Expenses (in $) in Miscellaneous expenses and Expenses (in $) in Grants and Revenue?
Ensure brevity in your answer.  -7.91e+09. In the year 2001, what is the difference between the Expenses (in $) in Miscellaneous expenses and Expenses (in $) in Services?
Keep it short and to the point. -7.88e+09. In the year 2001, what is the difference between the Expenses (in $) of Labor Taxes and Expenses (in $) of Grants and Revenue?
Ensure brevity in your answer.  -7.87e+09. In the year 2001, what is the difference between the Expenses (in $) of Labor Taxes and Expenses (in $) of Services?
Your answer should be compact. -7.84e+09. In the year 2001, what is the difference between the Expenses (in $) of Grants and Revenue and Expenses (in $) of Services?
Your response must be concise. 2.81e+07. In the year 2002, what is the difference between the Expenses (in $) of Miscellaneous expenses and Expenses (in $) of Labor Taxes?
Provide a succinct answer. 1.91e+09. In the year 2002, what is the difference between the Expenses (in $) of Miscellaneous expenses and Expenses (in $) of Grants and Revenue?
Your response must be concise. -1.08e+1. In the year 2002, what is the difference between the Expenses (in $) of Miscellaneous expenses and Expenses (in $) of Services?
Your response must be concise. -6.15e+09. In the year 2002, what is the difference between the Expenses (in $) in Labor Taxes and Expenses (in $) in Grants and Revenue?
Ensure brevity in your answer.  -1.27e+1. In the year 2002, what is the difference between the Expenses (in $) of Labor Taxes and Expenses (in $) of Services?
Give a very brief answer. -8.07e+09. In the year 2002, what is the difference between the Expenses (in $) in Grants and Revenue and Expenses (in $) in Services?
Offer a terse response. 4.66e+09. In the year 2003, what is the difference between the Expenses (in $) of Miscellaneous expenses and Expenses (in $) of Labor Taxes?
Your answer should be very brief. 3.17e+09. In the year 2003, what is the difference between the Expenses (in $) of Miscellaneous expenses and Expenses (in $) of Grants and Revenue?
Give a very brief answer. -1.13e+1. In the year 2003, what is the difference between the Expenses (in $) in Miscellaneous expenses and Expenses (in $) in Services?
Offer a terse response. -5.43e+09. In the year 2003, what is the difference between the Expenses (in $) in Labor Taxes and Expenses (in $) in Grants and Revenue?
Provide a succinct answer. -1.44e+1. In the year 2003, what is the difference between the Expenses (in $) of Labor Taxes and Expenses (in $) of Services?
Give a very brief answer. -8.60e+09. In the year 2003, what is the difference between the Expenses (in $) of Grants and Revenue and Expenses (in $) of Services?
Provide a short and direct response. 5.82e+09. In the year 2004, what is the difference between the Expenses (in $) of Miscellaneous expenses and Expenses (in $) of Labor Taxes?
Provide a succinct answer. 8.77e+09. In the year 2004, what is the difference between the Expenses (in $) of Miscellaneous expenses and Expenses (in $) of Grants and Revenue?
Your answer should be very brief. -7.23e+09. In the year 2004, what is the difference between the Expenses (in $) of Miscellaneous expenses and Expenses (in $) of Services?
Provide a succinct answer. -3.06e+09. In the year 2004, what is the difference between the Expenses (in $) of Labor Taxes and Expenses (in $) of Grants and Revenue?
Provide a succinct answer. -1.60e+1. In the year 2004, what is the difference between the Expenses (in $) in Labor Taxes and Expenses (in $) in Services?
Provide a short and direct response. -1.18e+1. In the year 2004, what is the difference between the Expenses (in $) in Grants and Revenue and Expenses (in $) in Services?
Provide a succinct answer. 4.16e+09. In the year 2005, what is the difference between the Expenses (in $) of Miscellaneous expenses and Expenses (in $) of Labor Taxes?
Your answer should be very brief. 6.82e+09. In the year 2005, what is the difference between the Expenses (in $) of Miscellaneous expenses and Expenses (in $) of Grants and Revenue?
Keep it short and to the point. -1.44e+1. In the year 2005, what is the difference between the Expenses (in $) of Miscellaneous expenses and Expenses (in $) of Services?
Give a very brief answer. -6.09e+09. In the year 2005, what is the difference between the Expenses (in $) of Labor Taxes and Expenses (in $) of Grants and Revenue?
Give a very brief answer. -2.12e+1. In the year 2005, what is the difference between the Expenses (in $) of Labor Taxes and Expenses (in $) of Services?
Your answer should be compact. -1.29e+1. In the year 2005, what is the difference between the Expenses (in $) of Grants and Revenue and Expenses (in $) of Services?
Give a very brief answer. 8.32e+09. In the year 2006, what is the difference between the Expenses (in $) in Miscellaneous expenses and Expenses (in $) in Labor Taxes?
Ensure brevity in your answer.  8.46e+09. In the year 2006, what is the difference between the Expenses (in $) of Miscellaneous expenses and Expenses (in $) of Grants and Revenue?
Your answer should be compact. -1.71e+1. In the year 2006, what is the difference between the Expenses (in $) in Miscellaneous expenses and Expenses (in $) in Services?
Ensure brevity in your answer.  -1.14e+1. In the year 2006, what is the difference between the Expenses (in $) in Labor Taxes and Expenses (in $) in Grants and Revenue?
Your answer should be very brief. -2.56e+1. In the year 2006, what is the difference between the Expenses (in $) in Labor Taxes and Expenses (in $) in Services?
Offer a terse response. -1.99e+1. In the year 2006, what is the difference between the Expenses (in $) in Grants and Revenue and Expenses (in $) in Services?
Offer a terse response. 5.72e+09. In the year 2007, what is the difference between the Expenses (in $) in Miscellaneous expenses and Expenses (in $) in Labor Taxes?
Give a very brief answer. 1.38e+1. In the year 2007, what is the difference between the Expenses (in $) in Miscellaneous expenses and Expenses (in $) in Grants and Revenue?
Provide a short and direct response. -1.80e+1. In the year 2007, what is the difference between the Expenses (in $) in Miscellaneous expenses and Expenses (in $) in Services?
Your answer should be compact. -1.01e+1. In the year 2007, what is the difference between the Expenses (in $) in Labor Taxes and Expenses (in $) in Grants and Revenue?
Offer a terse response. -3.18e+1. In the year 2007, what is the difference between the Expenses (in $) of Labor Taxes and Expenses (in $) of Services?
Offer a very short reply. -2.39e+1. In the year 2007, what is the difference between the Expenses (in $) in Grants and Revenue and Expenses (in $) in Services?
Offer a very short reply. 7.86e+09. What is the ratio of the Expenses (in $) of Miscellaneous expenses in 2001 to that in 2002?
Provide a short and direct response. 0.43. What is the ratio of the Expenses (in $) of Labor Taxes in 2001 to that in 2002?
Offer a terse response. 41.99. What is the ratio of the Expenses (in $) in Grants and Revenue in 2001 to that in 2002?
Ensure brevity in your answer.  0.69. What is the ratio of the Expenses (in $) of Services in 2001 to that in 2002?
Keep it short and to the point. 1.08. What is the ratio of the Expenses (in $) in Miscellaneous expenses in 2001 to that in 2003?
Give a very brief answer. 0.25. What is the ratio of the Expenses (in $) in Labor Taxes in 2001 to that in 2003?
Your response must be concise. 5.19. What is the ratio of the Expenses (in $) of Grants and Revenue in 2001 to that in 2003?
Keep it short and to the point. 0.6. What is the ratio of the Expenses (in $) in Services in 2001 to that in 2003?
Your response must be concise. 0.99. What is the ratio of the Expenses (in $) in Miscellaneous expenses in 2001 to that in 2004?
Your answer should be very brief. 0.09. What is the ratio of the Expenses (in $) of Labor Taxes in 2001 to that in 2004?
Your response must be concise. 11.08. What is the ratio of the Expenses (in $) in Grants and Revenue in 2001 to that in 2004?
Provide a succinct answer. 0.54. What is the ratio of the Expenses (in $) of Services in 2001 to that in 2004?
Offer a very short reply. 0.73. What is the ratio of the Expenses (in $) in Miscellaneous expenses in 2001 to that in 2005?
Your answer should be very brief. 0.12. What is the ratio of the Expenses (in $) of Labor Taxes in 2001 to that in 2005?
Your answer should be compact. 19.98. What is the ratio of the Expenses (in $) in Grants and Revenue in 2001 to that in 2005?
Make the answer very short. 0.41. What is the ratio of the Expenses (in $) in Services in 2001 to that in 2005?
Offer a terse response. 0.67. What is the ratio of the Expenses (in $) in Miscellaneous expenses in 2001 to that in 2006?
Offer a very short reply. 0.1. What is the ratio of the Expenses (in $) in Labor Taxes in 2001 to that in 2006?
Your answer should be compact. 60.35. What is the ratio of the Expenses (in $) of Grants and Revenue in 2001 to that in 2006?
Offer a terse response. 0.34. What is the ratio of the Expenses (in $) in Services in 2001 to that in 2006?
Your answer should be very brief. 0.44. What is the ratio of the Expenses (in $) of Miscellaneous expenses in 2001 to that in 2007?
Your answer should be very brief. 0.06. What is the ratio of the Expenses (in $) in Labor Taxes in 2001 to that in 2007?
Give a very brief answer. 103.46. What is the ratio of the Expenses (in $) in Grants and Revenue in 2001 to that in 2007?
Your answer should be compact. 0.28. What is the ratio of the Expenses (in $) of Services in 2001 to that in 2007?
Your answer should be very brief. 0.36. What is the ratio of the Expenses (in $) in Miscellaneous expenses in 2002 to that in 2003?
Ensure brevity in your answer.  0.58. What is the ratio of the Expenses (in $) of Labor Taxes in 2002 to that in 2003?
Give a very brief answer. 0.12. What is the ratio of the Expenses (in $) in Grants and Revenue in 2002 to that in 2003?
Your answer should be compact. 0.87. What is the ratio of the Expenses (in $) in Services in 2002 to that in 2003?
Make the answer very short. 0.92. What is the ratio of the Expenses (in $) in Miscellaneous expenses in 2002 to that in 2004?
Your response must be concise. 0.22. What is the ratio of the Expenses (in $) in Labor Taxes in 2002 to that in 2004?
Give a very brief answer. 0.26. What is the ratio of the Expenses (in $) in Grants and Revenue in 2002 to that in 2004?
Your answer should be compact. 0.79. What is the ratio of the Expenses (in $) of Services in 2002 to that in 2004?
Keep it short and to the point. 0.68. What is the ratio of the Expenses (in $) of Miscellaneous expenses in 2002 to that in 2005?
Offer a terse response. 0.28. What is the ratio of the Expenses (in $) of Labor Taxes in 2002 to that in 2005?
Provide a succinct answer. 0.48. What is the ratio of the Expenses (in $) in Grants and Revenue in 2002 to that in 2005?
Provide a succinct answer. 0.6. What is the ratio of the Expenses (in $) of Services in 2002 to that in 2005?
Ensure brevity in your answer.  0.62. What is the ratio of the Expenses (in $) of Miscellaneous expenses in 2002 to that in 2006?
Give a very brief answer. 0.23. What is the ratio of the Expenses (in $) of Labor Taxes in 2002 to that in 2006?
Provide a succinct answer. 1.44. What is the ratio of the Expenses (in $) of Grants and Revenue in 2002 to that in 2006?
Provide a short and direct response. 0.5. What is the ratio of the Expenses (in $) of Services in 2002 to that in 2006?
Make the answer very short. 0.41. What is the ratio of the Expenses (in $) of Miscellaneous expenses in 2002 to that in 2007?
Give a very brief answer. 0.14. What is the ratio of the Expenses (in $) in Labor Taxes in 2002 to that in 2007?
Ensure brevity in your answer.  2.46. What is the ratio of the Expenses (in $) of Grants and Revenue in 2002 to that in 2007?
Offer a terse response. 0.4. What is the ratio of the Expenses (in $) in Services in 2002 to that in 2007?
Your answer should be very brief. 0.34. What is the ratio of the Expenses (in $) in Miscellaneous expenses in 2003 to that in 2004?
Keep it short and to the point. 0.38. What is the ratio of the Expenses (in $) in Labor Taxes in 2003 to that in 2004?
Keep it short and to the point. 2.13. What is the ratio of the Expenses (in $) of Grants and Revenue in 2003 to that in 2004?
Your response must be concise. 0.91. What is the ratio of the Expenses (in $) in Services in 2003 to that in 2004?
Offer a very short reply. 0.74. What is the ratio of the Expenses (in $) in Miscellaneous expenses in 2003 to that in 2005?
Your answer should be compact. 0.49. What is the ratio of the Expenses (in $) of Labor Taxes in 2003 to that in 2005?
Give a very brief answer. 3.85. What is the ratio of the Expenses (in $) of Grants and Revenue in 2003 to that in 2005?
Keep it short and to the point. 0.69. What is the ratio of the Expenses (in $) in Services in 2003 to that in 2005?
Your answer should be compact. 0.68. What is the ratio of the Expenses (in $) in Miscellaneous expenses in 2003 to that in 2006?
Provide a short and direct response. 0.39. What is the ratio of the Expenses (in $) of Labor Taxes in 2003 to that in 2006?
Keep it short and to the point. 11.63. What is the ratio of the Expenses (in $) of Grants and Revenue in 2003 to that in 2006?
Keep it short and to the point. 0.57. What is the ratio of the Expenses (in $) in Services in 2003 to that in 2006?
Provide a succinct answer. 0.44. What is the ratio of the Expenses (in $) in Miscellaneous expenses in 2003 to that in 2007?
Keep it short and to the point. 0.24. What is the ratio of the Expenses (in $) of Labor Taxes in 2003 to that in 2007?
Your answer should be very brief. 19.93. What is the ratio of the Expenses (in $) of Grants and Revenue in 2003 to that in 2007?
Offer a very short reply. 0.46. What is the ratio of the Expenses (in $) in Services in 2003 to that in 2007?
Provide a short and direct response. 0.37. What is the ratio of the Expenses (in $) in Miscellaneous expenses in 2004 to that in 2005?
Your response must be concise. 1.29. What is the ratio of the Expenses (in $) of Labor Taxes in 2004 to that in 2005?
Ensure brevity in your answer.  1.8. What is the ratio of the Expenses (in $) of Grants and Revenue in 2004 to that in 2005?
Provide a succinct answer. 0.76. What is the ratio of the Expenses (in $) in Services in 2004 to that in 2005?
Your answer should be very brief. 0.92. What is the ratio of the Expenses (in $) of Miscellaneous expenses in 2004 to that in 2006?
Your response must be concise. 1.04. What is the ratio of the Expenses (in $) in Labor Taxes in 2004 to that in 2006?
Give a very brief answer. 5.45. What is the ratio of the Expenses (in $) in Grants and Revenue in 2004 to that in 2006?
Keep it short and to the point. 0.63. What is the ratio of the Expenses (in $) in Services in 2004 to that in 2006?
Your response must be concise. 0.6. What is the ratio of the Expenses (in $) in Miscellaneous expenses in 2004 to that in 2007?
Ensure brevity in your answer.  0.64. What is the ratio of the Expenses (in $) of Labor Taxes in 2004 to that in 2007?
Ensure brevity in your answer.  9.34. What is the ratio of the Expenses (in $) of Grants and Revenue in 2004 to that in 2007?
Make the answer very short. 0.51. What is the ratio of the Expenses (in $) of Services in 2004 to that in 2007?
Give a very brief answer. 0.5. What is the ratio of the Expenses (in $) in Miscellaneous expenses in 2005 to that in 2006?
Give a very brief answer. 0.81. What is the ratio of the Expenses (in $) in Labor Taxes in 2005 to that in 2006?
Make the answer very short. 3.02. What is the ratio of the Expenses (in $) of Grants and Revenue in 2005 to that in 2006?
Give a very brief answer. 0.83. What is the ratio of the Expenses (in $) in Services in 2005 to that in 2006?
Provide a short and direct response. 0.65. What is the ratio of the Expenses (in $) in Miscellaneous expenses in 2005 to that in 2007?
Your answer should be compact. 0.5. What is the ratio of the Expenses (in $) in Labor Taxes in 2005 to that in 2007?
Provide a short and direct response. 5.18. What is the ratio of the Expenses (in $) of Grants and Revenue in 2005 to that in 2007?
Your answer should be compact. 0.67. What is the ratio of the Expenses (in $) of Services in 2005 to that in 2007?
Give a very brief answer. 0.54. What is the ratio of the Expenses (in $) in Miscellaneous expenses in 2006 to that in 2007?
Give a very brief answer. 0.61. What is the ratio of the Expenses (in $) of Labor Taxes in 2006 to that in 2007?
Provide a short and direct response. 1.71. What is the ratio of the Expenses (in $) of Grants and Revenue in 2006 to that in 2007?
Ensure brevity in your answer.  0.81. What is the ratio of the Expenses (in $) of Services in 2006 to that in 2007?
Provide a short and direct response. 0.83. What is the difference between the highest and the second highest Expenses (in $) in Miscellaneous expenses?
Offer a terse response. 4.96e+09. What is the difference between the highest and the second highest Expenses (in $) in Labor Taxes?
Give a very brief answer. 7.02e+08. What is the difference between the highest and the second highest Expenses (in $) of Grants and Revenue?
Ensure brevity in your answer.  6.17e+09. What is the difference between the highest and the second highest Expenses (in $) of Services?
Offer a terse response. 4.02e+09. What is the difference between the highest and the lowest Expenses (in $) of Miscellaneous expenses?
Offer a very short reply. 1.30e+1. What is the difference between the highest and the lowest Expenses (in $) of Labor Taxes?
Your answer should be very brief. 8.61e+08. What is the difference between the highest and the lowest Expenses (in $) of Grants and Revenue?
Give a very brief answer. 2.30e+1. What is the difference between the highest and the lowest Expenses (in $) of Services?
Your answer should be compact. 1.58e+1. 